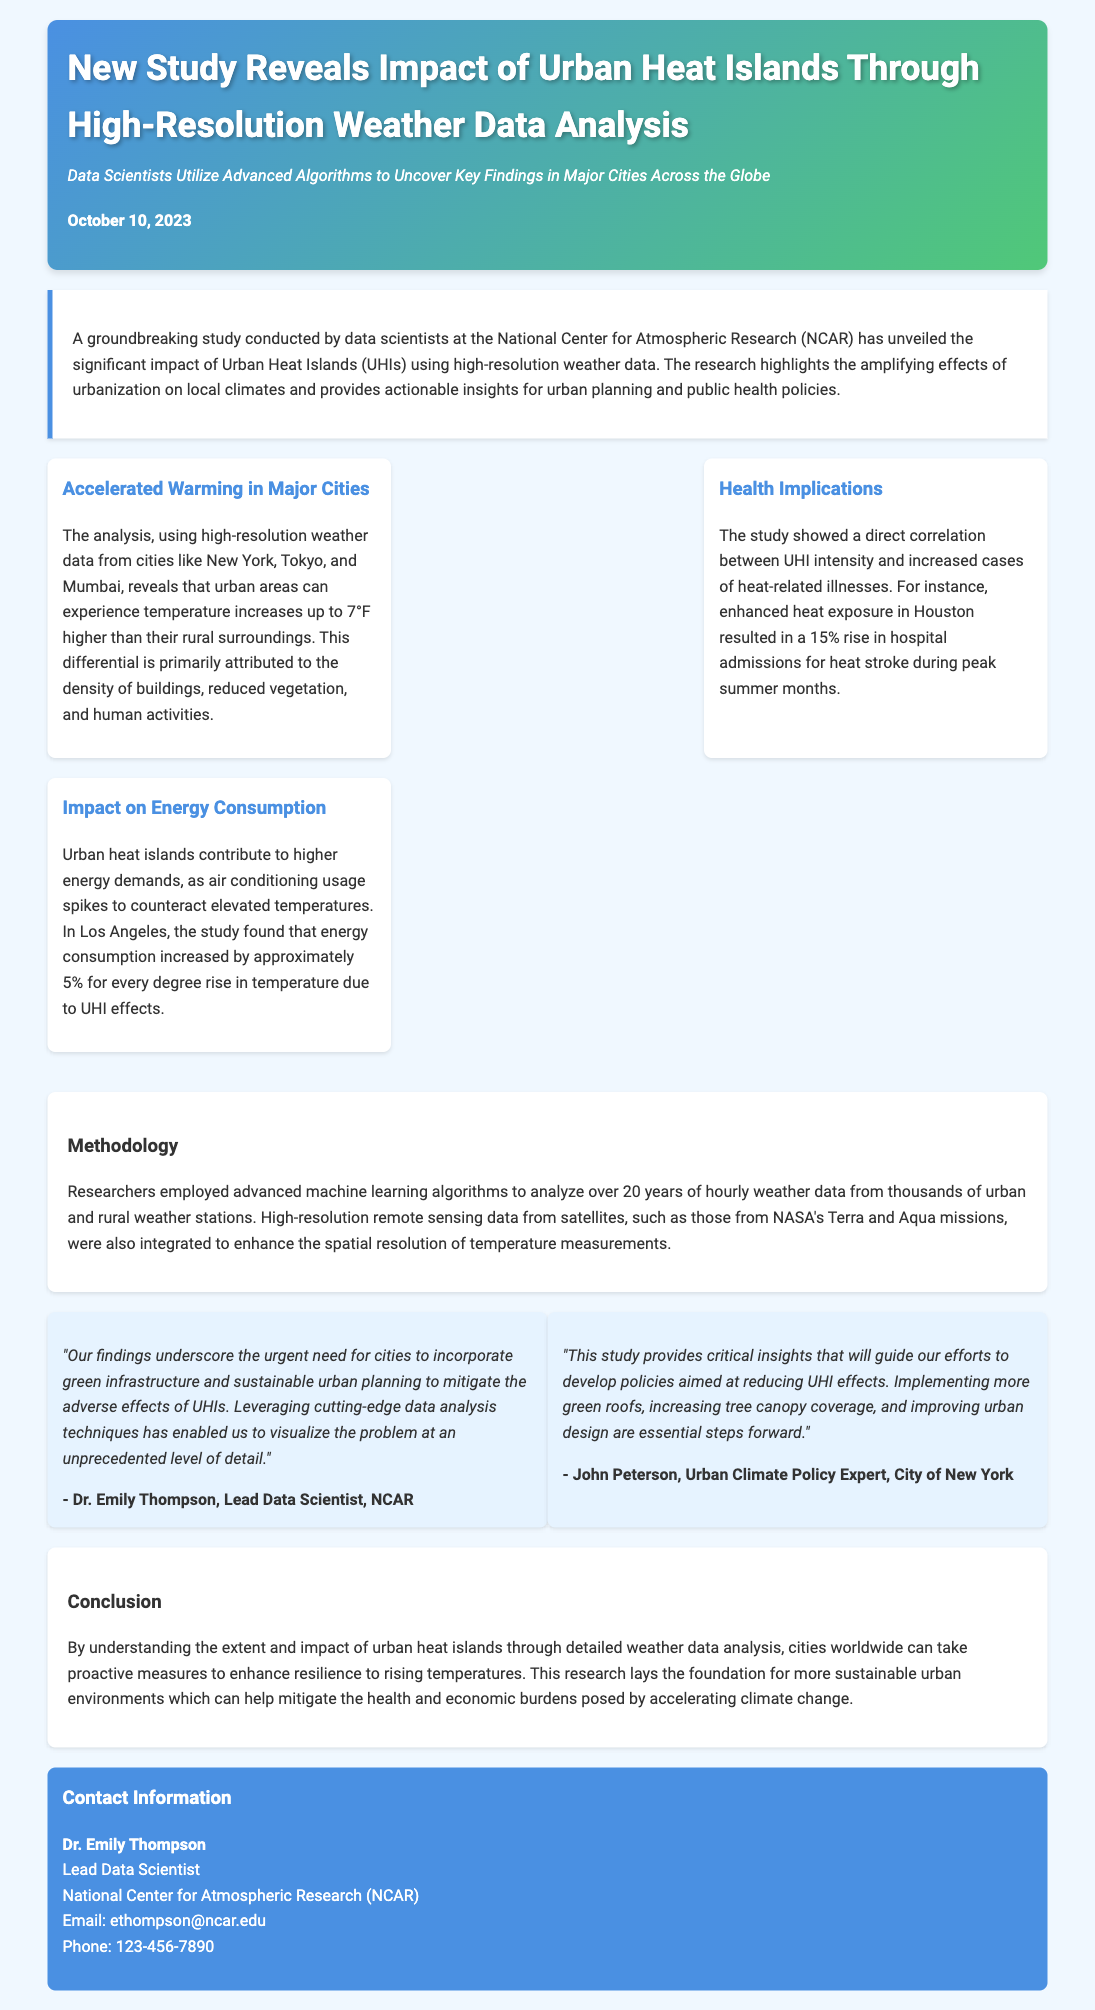What is the date of the press release? The date mentioned in the document is when the study was released, which is stated as October 10, 2023.
Answer: October 10, 2023 Who conducted the study? The document specifies that the study was conducted by data scientists at the National Center for Atmospheric Research (NCAR).
Answer: NCAR What temperature increase can urban areas experience according to the study? The document states that urban areas can experience temperature increases up to 7°F higher than rural surroundings.
Answer: 7°F What is the percentage rise in hospital admissions for heat stroke in Houston? The document notes a 15% rise in hospital admissions for heat stroke during peak summer months due to UHI effects.
Answer: 15% Which cities were used in the analysis? The study utilized high-resolution weather data from cities including New York, Tokyo, and Mumbai.
Answer: New York, Tokyo, and Mumbai What methodological approach was used in the research? The document mentions that advanced machine learning algorithms were employed to analyze the data.
Answer: Machine learning algorithms What correlation does the study show regarding UHI effects? It shows a direct correlation between UHI intensity and increased cases of heat-related illnesses.
Answer: Direct correlation What should cities incorporate according to Dr. Emily Thompson? The document indicates that cities should incorporate green infrastructure and sustainable urban planning.
Answer: Green infrastructure What is the contact email of Dr. Emily Thompson? The document provides the email for Dr. Emily Thompson as ethompson@ncar.edu.
Answer: ethompson@ncar.edu 